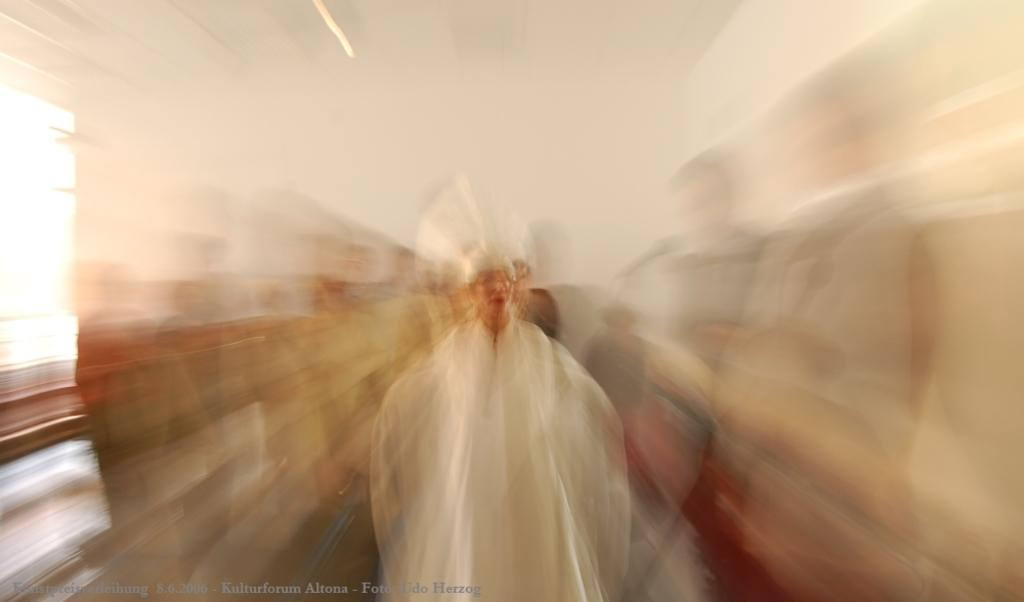What is the overall quality of the image? The image is blurry. Can you identify any subjects in the image? Yes, there are people in the image. Is there any text present in the image? Yes, there is text in the bottom left hand corner of the image. What type of division is being discussed by the expert in the image? There is no expert or division present in the image; it is a blurry image with people and text. 